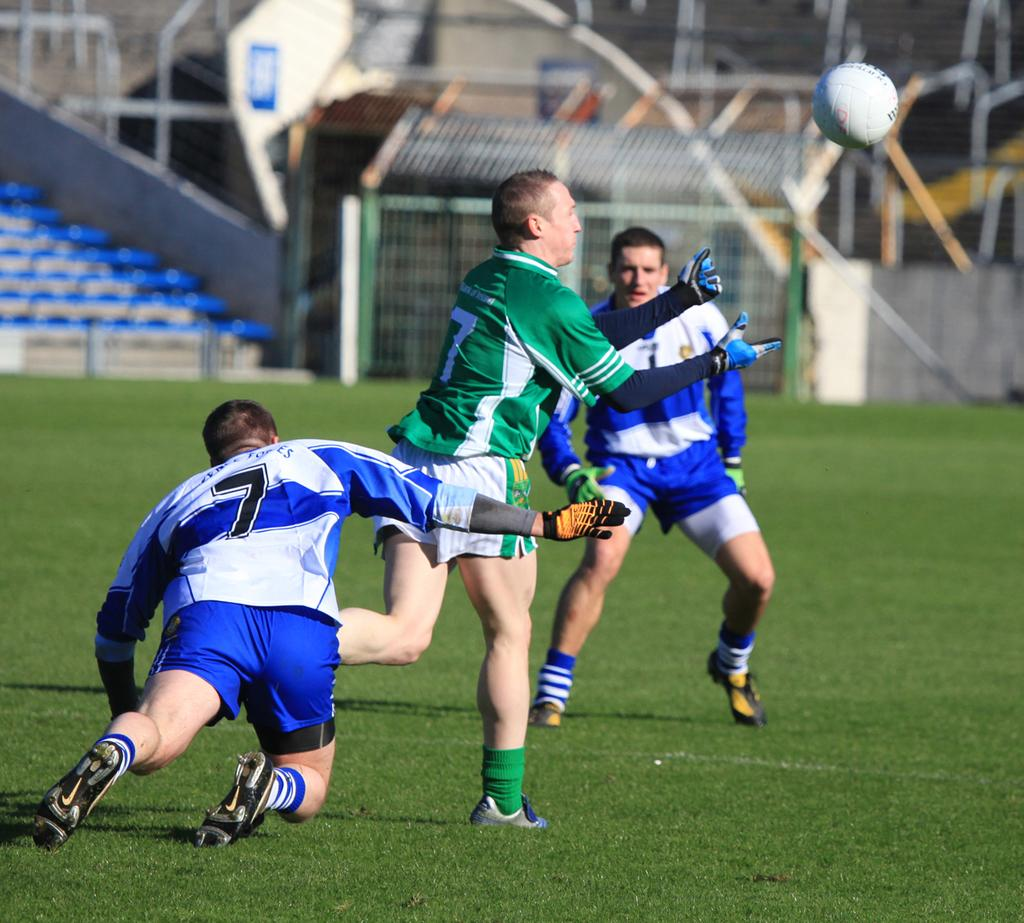<image>
Present a compact description of the photo's key features. The white team's number 7 dives after the green team's number 7 while they go for the ball. 